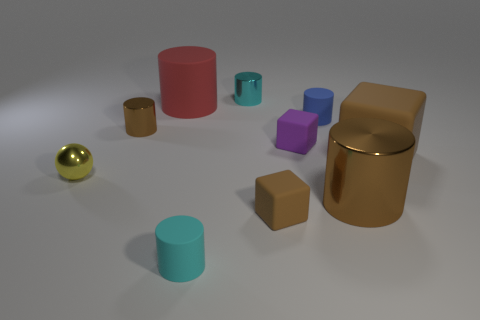Subtract all tiny brown shiny cylinders. How many cylinders are left? 5 Subtract all red cylinders. How many cylinders are left? 5 Subtract all green cylinders. Subtract all yellow balls. How many cylinders are left? 6 Subtract all cylinders. How many objects are left? 4 Subtract 0 blue blocks. How many objects are left? 10 Subtract all brown shiny cylinders. Subtract all purple matte cubes. How many objects are left? 7 Add 7 cubes. How many cubes are left? 10 Add 9 small yellow metallic objects. How many small yellow metallic objects exist? 10 